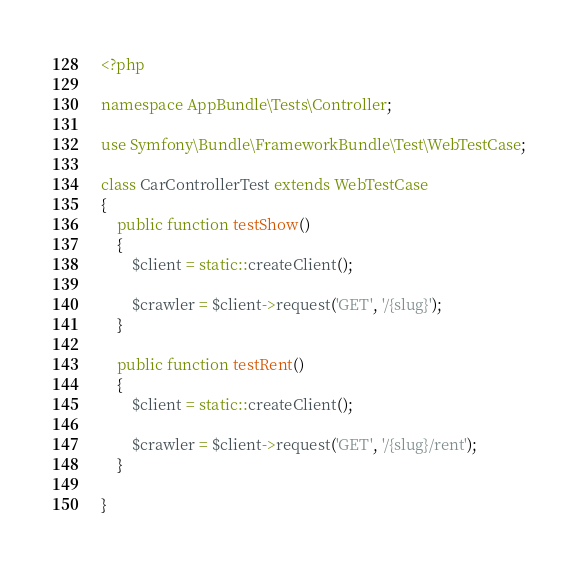Convert code to text. <code><loc_0><loc_0><loc_500><loc_500><_PHP_><?php

namespace AppBundle\Tests\Controller;

use Symfony\Bundle\FrameworkBundle\Test\WebTestCase;

class CarControllerTest extends WebTestCase
{
    public function testShow()
    {
        $client = static::createClient();

        $crawler = $client->request('GET', '/{slug}');
    }

    public function testRent()
    {
        $client = static::createClient();

        $crawler = $client->request('GET', '/{slug}/rent');
    }

}
</code> 